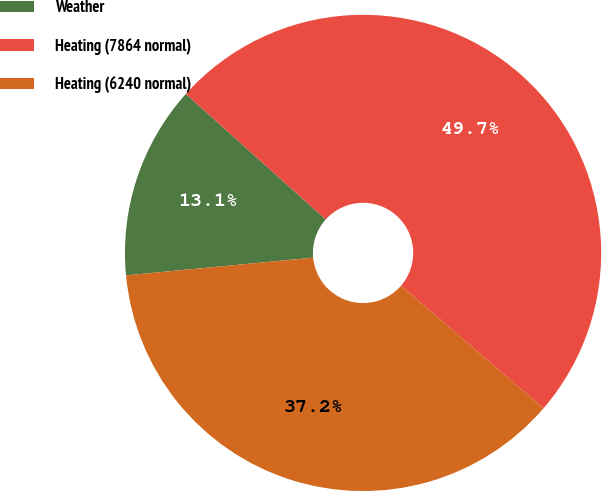<chart> <loc_0><loc_0><loc_500><loc_500><pie_chart><fcel>Weather<fcel>Heating (7864 normal)<fcel>Heating (6240 normal)<nl><fcel>13.14%<fcel>49.68%<fcel>37.18%<nl></chart> 